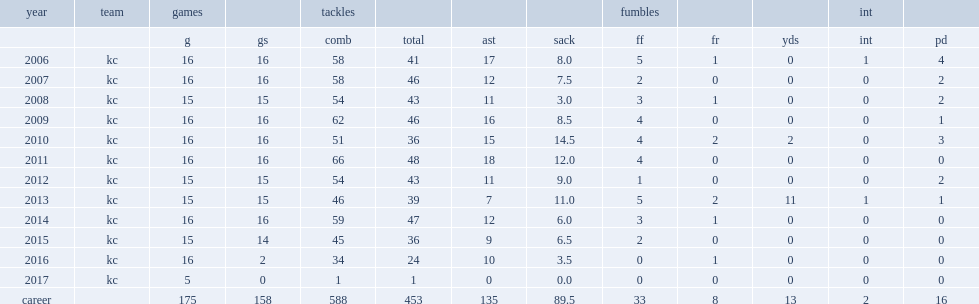How many sacks did hali have in 2010? 14.5. Could you parse the entire table as a dict? {'header': ['year', 'team', 'games', '', 'tackles', '', '', '', 'fumbles', '', '', 'int', ''], 'rows': [['', '', 'g', 'gs', 'comb', 'total', 'ast', 'sack', 'ff', 'fr', 'yds', 'int', 'pd'], ['2006', 'kc', '16', '16', '58', '41', '17', '8.0', '5', '1', '0', '1', '4'], ['2007', 'kc', '16', '16', '58', '46', '12', '7.5', '2', '0', '0', '0', '2'], ['2008', 'kc', '15', '15', '54', '43', '11', '3.0', '3', '1', '0', '0', '2'], ['2009', 'kc', '16', '16', '62', '46', '16', '8.5', '4', '0', '0', '0', '1'], ['2010', 'kc', '16', '16', '51', '36', '15', '14.5', '4', '2', '2', '0', '3'], ['2011', 'kc', '16', '16', '66', '48', '18', '12.0', '4', '0', '0', '0', '0'], ['2012', 'kc', '15', '15', '54', '43', '11', '9.0', '1', '0', '0', '0', '2'], ['2013', 'kc', '15', '15', '46', '39', '7', '11.0', '5', '2', '11', '1', '1'], ['2014', 'kc', '16', '16', '59', '47', '12', '6.0', '3', '1', '0', '0', '0'], ['2015', 'kc', '15', '14', '45', '36', '9', '6.5', '2', '0', '0', '0', '0'], ['2016', 'kc', '16', '2', '34', '24', '10', '3.5', '0', '1', '0', '0', '0'], ['2017', 'kc', '5', '0', '1', '1', '0', '0.0', '0', '0', '0', '0', '0'], ['career', '', '175', '158', '588', '453', '135', '89.5', '33', '8', '13', '2', '16']]} 